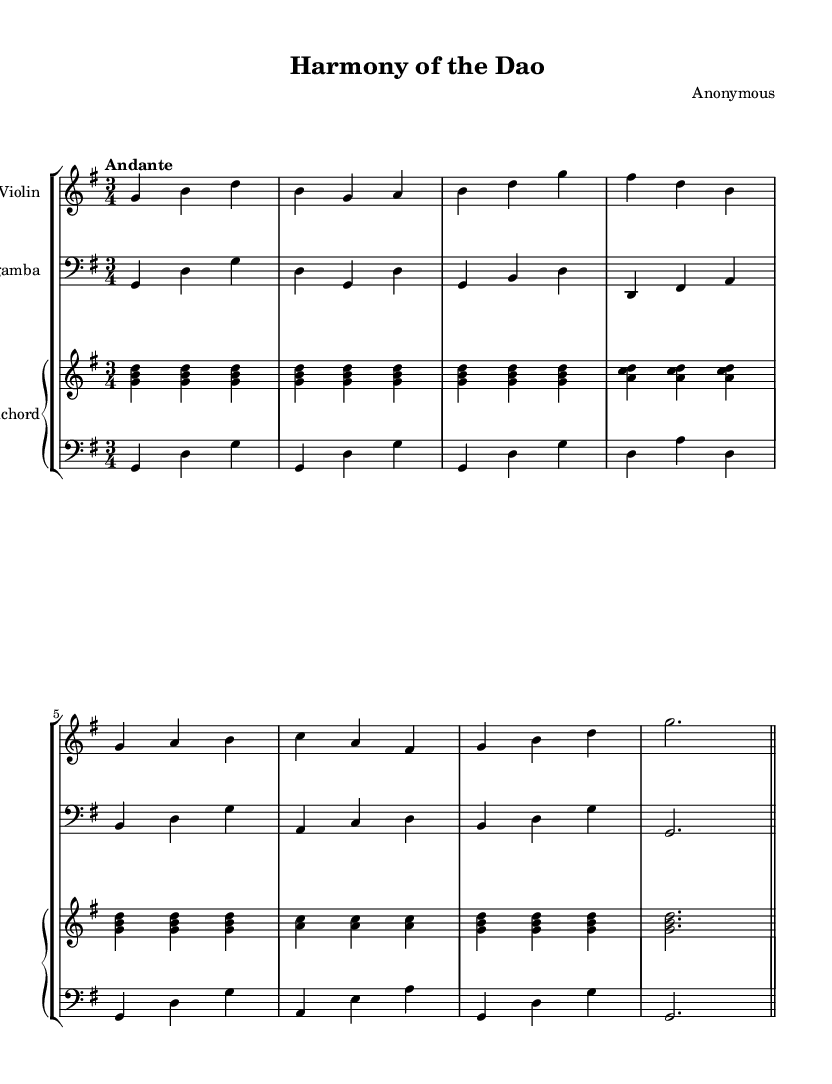What is the key signature of this music? The key signature is G major, which contains one sharp (F#). This is indicated at the beginning of the sheet music.
Answer: G major What is the time signature of this piece? The time signature is 3/4, shown at the beginning of the sheet music with a common-time symbol. This indicates that there are three beats in each measure, and the quarter note gets one beat.
Answer: 3/4 What is the tempo marking for this music? The tempo marking is "Andante," which is typically interpreted as a moderate walking pace. It is indicated at the beginning along with the other musical notations.
Answer: Andante How many measures are there in the violin part? To find the number of measures in the violin part, we count the vertical bar lines. The violin part has 8 measures as indicated by 8 vertical bar lines separating the phrases.
Answer: 8 Which instruments are involved in this chamber music piece? The instruments explicitly listed in the score are violin, viola da gamba, and harpsichord, as seen in the staff groupings and labels.
Answer: Violin, viola da gamba, harpsichord What style does this music represent? This music represents Baroque style, characterized by its distinct ornamentation, complex counterpoint, and emphasis on contrast. This can be inferred from the instrumentation and the musical form typical of the period.
Answer: Baroque 